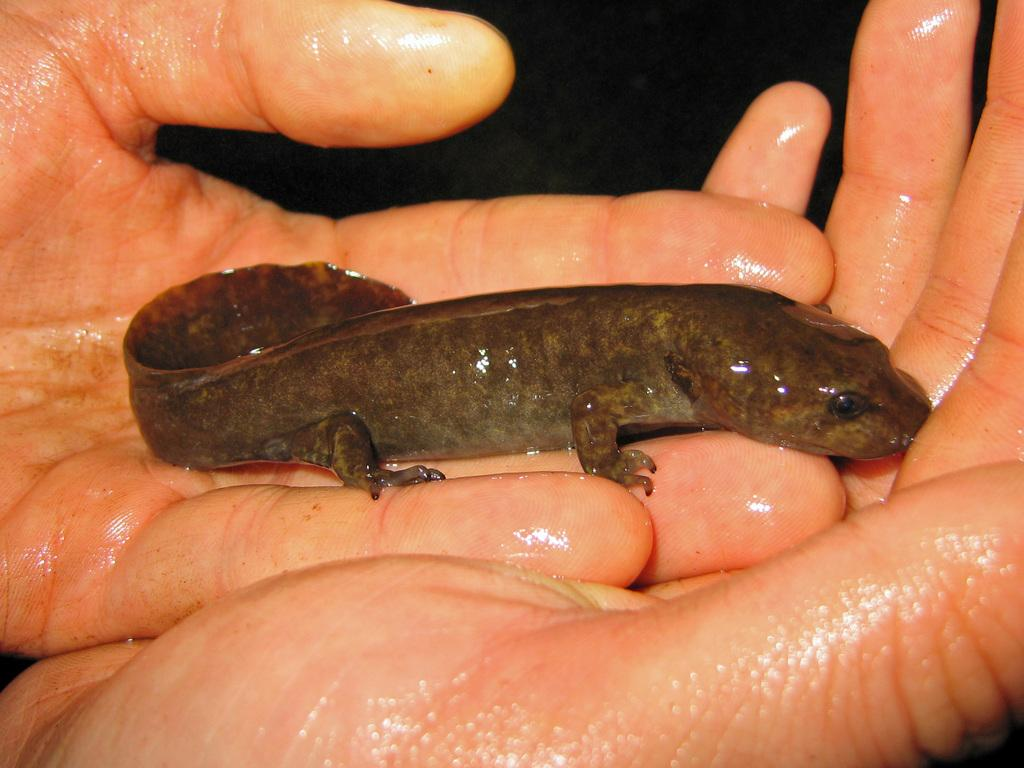What type of animal is in the image? There is a reptile in the image. How is the reptile being held or interacted with in the image? The reptile is on the hands of a person. What time of day is it in the image, and how does the thunder sound? There is no mention of time of day or thunder in the image, as it features a reptile on the hands of a person. 